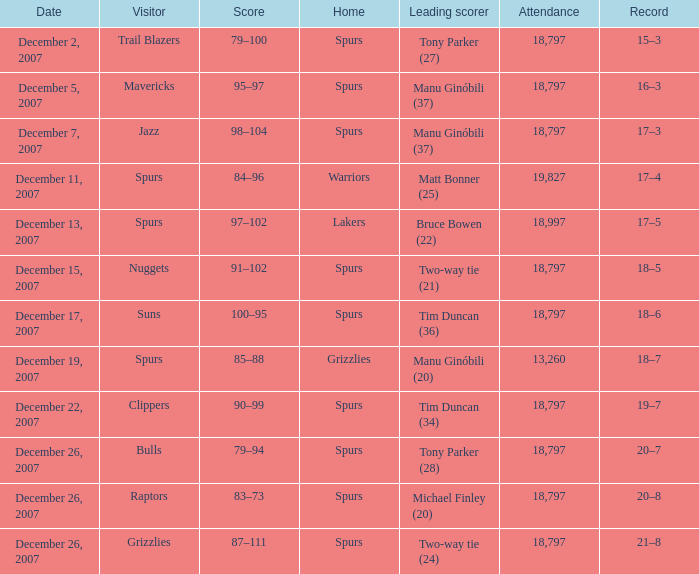What is the highest attendace of the game with the Lakers as the home team? 18997.0. 